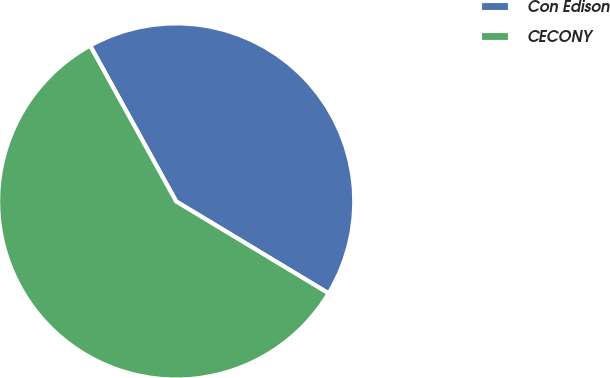Convert chart. <chart><loc_0><loc_0><loc_500><loc_500><pie_chart><fcel>Con Edison<fcel>CECONY<nl><fcel>41.67%<fcel>58.33%<nl></chart> 